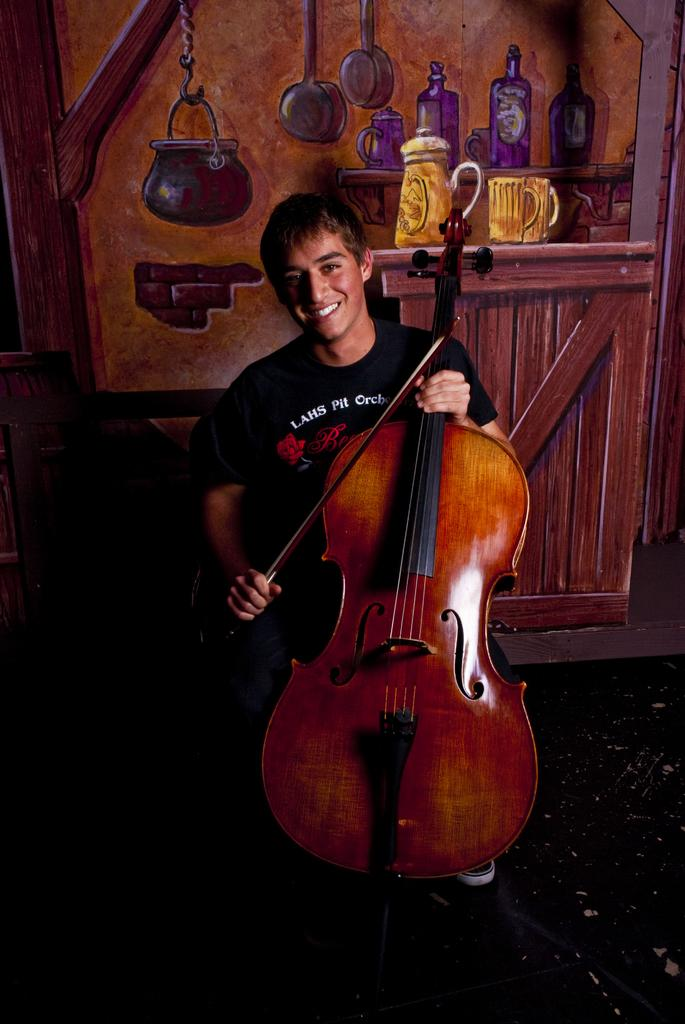Who or what is the main subject in the center of the image? There is a person in the center of the image. What is the person holding? The person is holding a violin. What can be seen in the background of the image? There is a wall in the background of the image. What is on the wall in the background? There is a painting on the wall. What is located on the left side of the image? There is a chair on the left side of the image. What type of sugar is being used to sweeten the jam in the image? There is no sugar or jam present in the image; it features a person holding a violin with a wall and painting in the background, and a chair on the left side. 